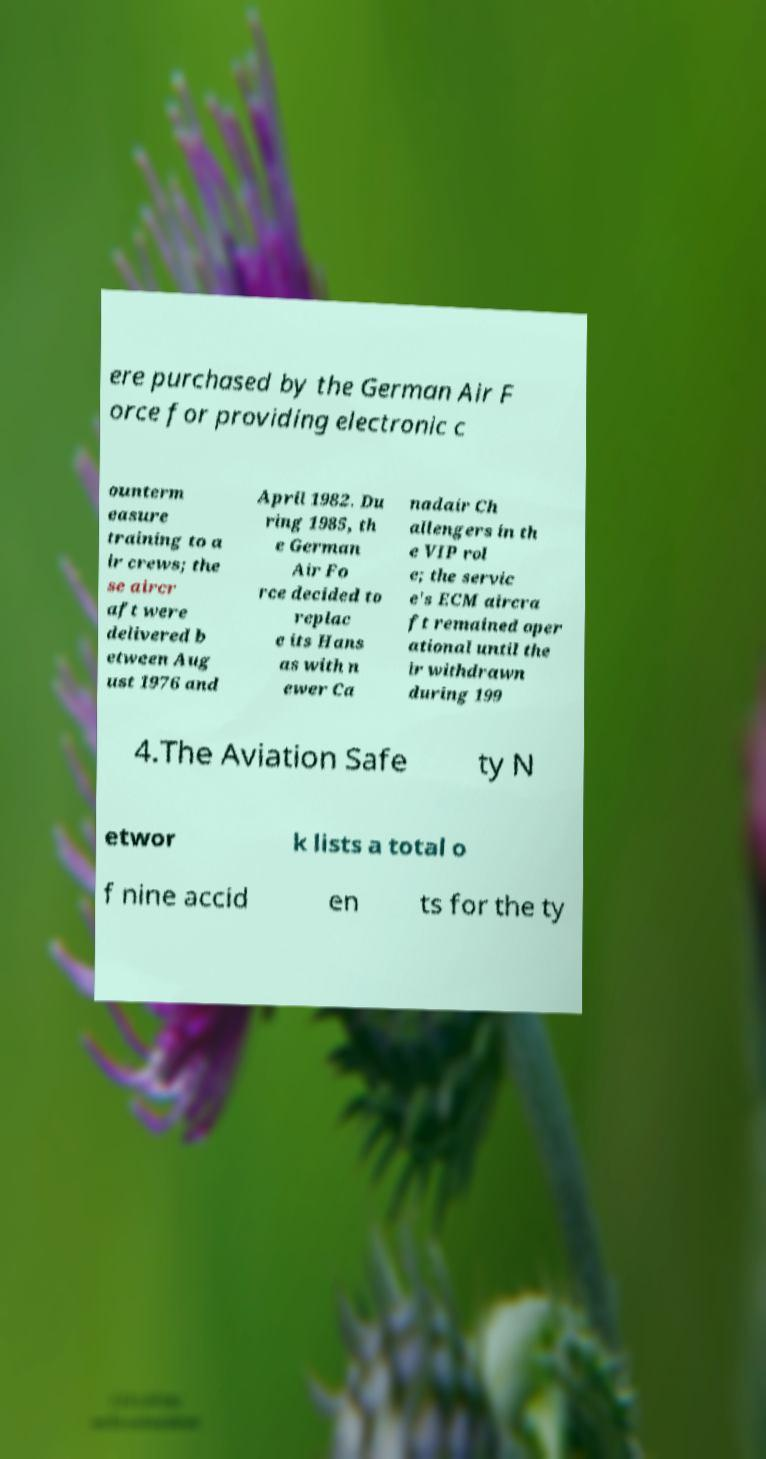Can you accurately transcribe the text from the provided image for me? ere purchased by the German Air F orce for providing electronic c ounterm easure training to a ir crews; the se aircr aft were delivered b etween Aug ust 1976 and April 1982. Du ring 1985, th e German Air Fo rce decided to replac e its Hans as with n ewer Ca nadair Ch allengers in th e VIP rol e; the servic e's ECM aircra ft remained oper ational until the ir withdrawn during 199 4.The Aviation Safe ty N etwor k lists a total o f nine accid en ts for the ty 